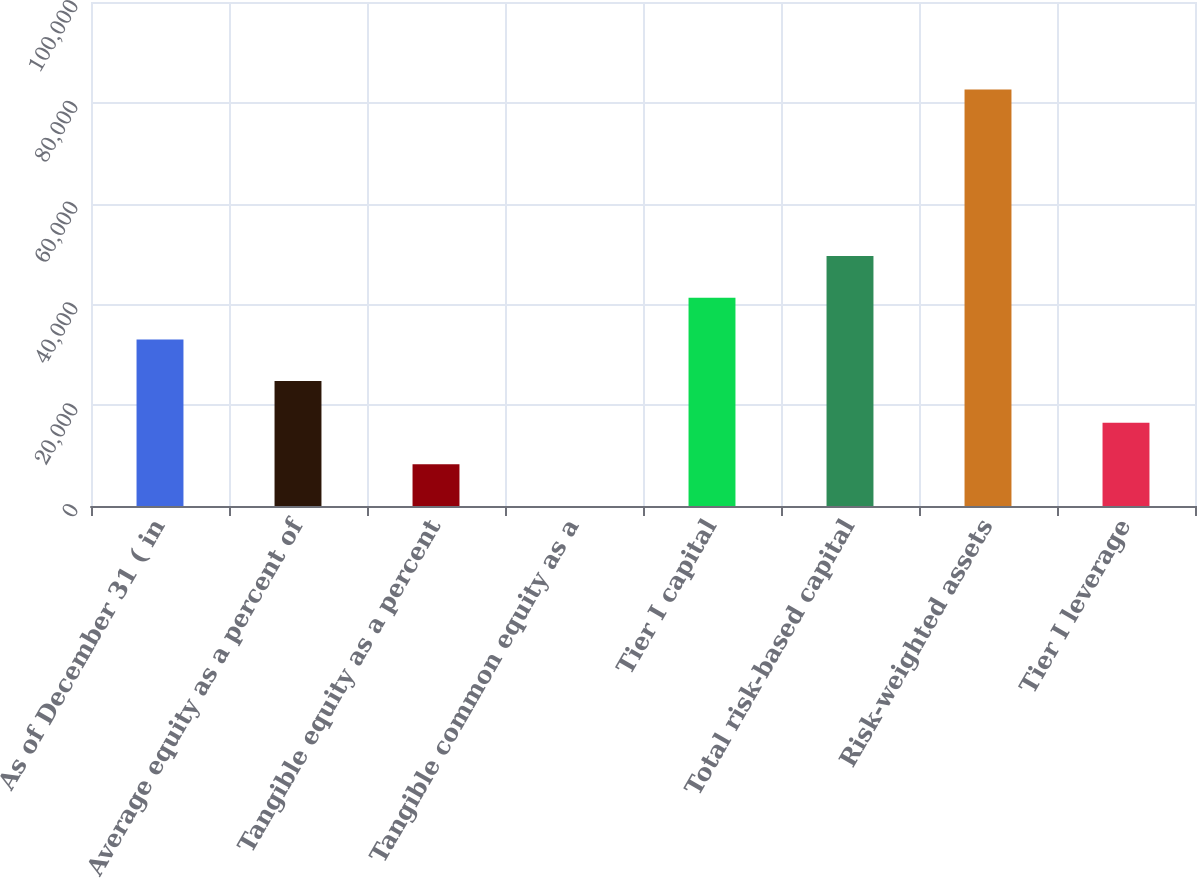<chart> <loc_0><loc_0><loc_500><loc_500><bar_chart><fcel>As of December 31 ( in<fcel>Average equity as a percent of<fcel>Tangible equity as a percent<fcel>Tangible common equity as a<fcel>Tier I capital<fcel>Total risk-based capital<fcel>Risk-weighted assets<fcel>Tier I leverage<nl><fcel>33058.3<fcel>24795.8<fcel>8270.95<fcel>8.5<fcel>41320.8<fcel>49583.2<fcel>82633<fcel>16533.4<nl></chart> 